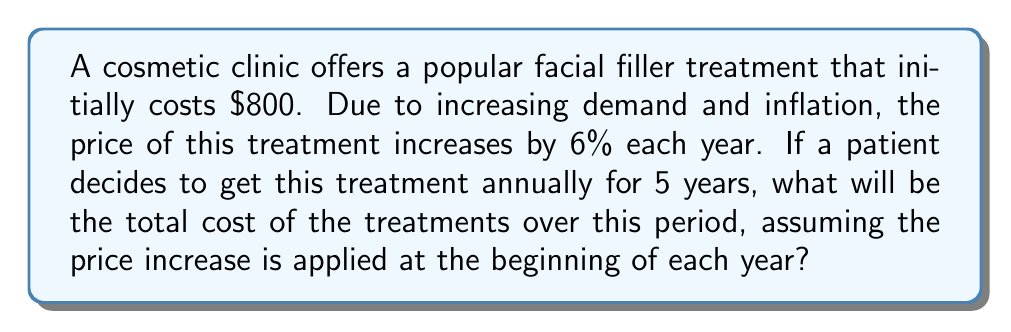Give your solution to this math problem. Let's approach this step-by-step:

1) The initial cost is $800, and it increases by 6% each year.

2) We can use the compound interest formula:
   $$A = P(1 + r)^n$$
   Where:
   $A$ = Final amount
   $P$ = Principal (initial amount)
   $r$ = Interest rate (as a decimal)
   $n$ = Number of years

3) We need to calculate the cost for each year:

   Year 1: $800
   Year 2: $800 * (1 + 0.06) = $848
   Year 3: $800 * (1 + 0.06)^2 = $898.88
   Year 4: $800 * (1 + 0.06)^3 = $952.81
   Year 5: $800 * (1 + 0.06)^4 = $1,009.98

4) To get the total cost, we sum these amounts:

   $$\text{Total} = 800 + 848 + 898.88 + 952.81 + 1009.98$$

5) Calculating this sum:

   $$\text{Total} = $4,509.67$$

6) Rounding to the nearest cent:

   $$\text{Total} = $4,509.67$$
Answer: $4,509.67 